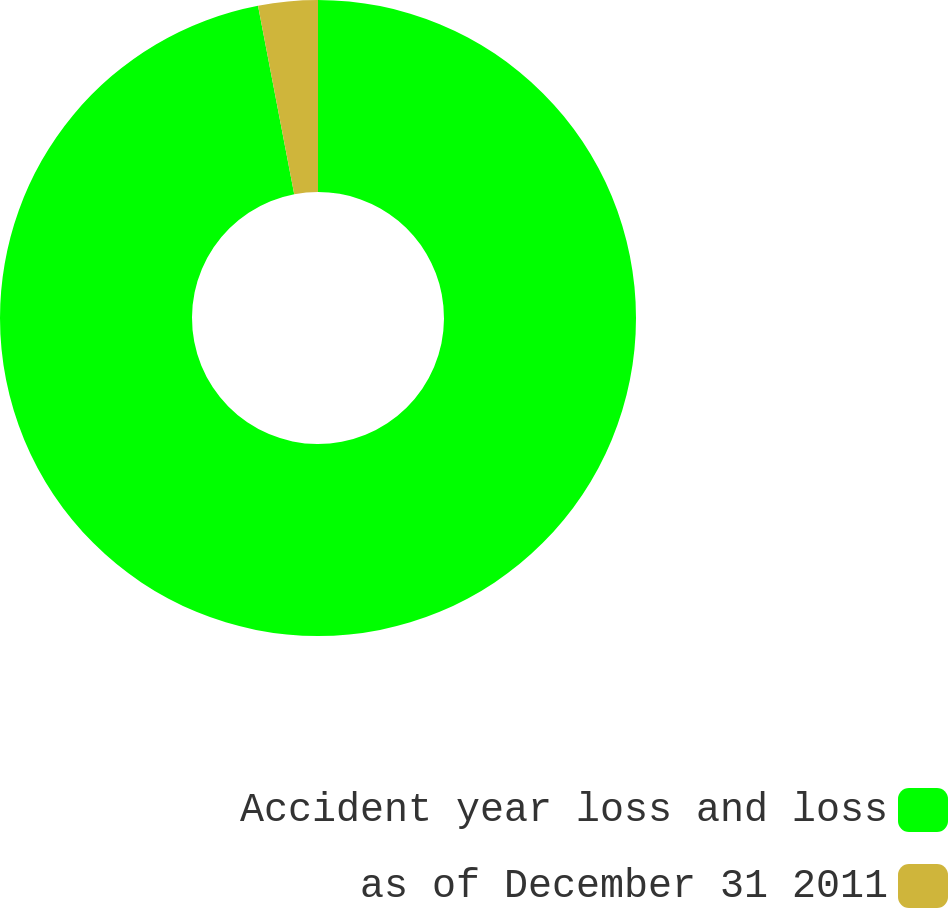<chart> <loc_0><loc_0><loc_500><loc_500><pie_chart><fcel>Accident year loss and loss<fcel>as of December 31 2011<nl><fcel>96.98%<fcel>3.02%<nl></chart> 